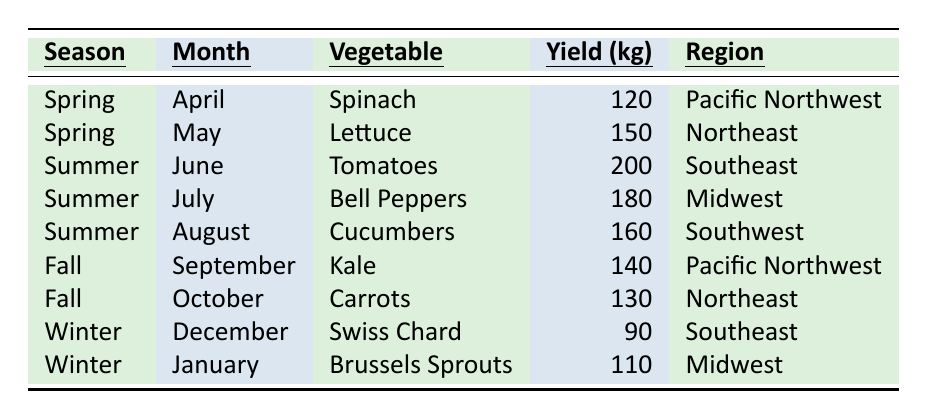What vegetables were harvested in the summer of 2023? In the table, under the summer season, the vegetables listed are Tomatoes in June, Bell Peppers in July, and Cucumbers in August.
Answer: Tomatoes, Bell Peppers, Cucumbers Which region yielded the highest amount of vegetables in 2023? The maximum yield in the table is 200 kg from the Southeast region for Tomatoes. Hence, the Southeast had the highest yield.
Answer: Southeast How many kg of Kale were harvested in the Fall? The yield of Kale mentioned in the table is 140 kg for Fall, specifically in September.
Answer: 140 kg What is the total yield of vegetables harvested in the winter? For winter, there are two vegetables: Swiss Chard in December with 90 kg and Brussels Sprouts in January with 110 kg. Adding these two yields gives 90 kg + 110 kg = 200 kg.
Answer: 200 kg Was the yield of Cucumbers higher than that of Lettuce? The yield for Cucumbers is 160 kg, while Lettuce's yield is 150 kg. Since 160 kg is greater than 150 kg, the statement is true.
Answer: Yes Calculate the average yield of vegetables across all seasons. The total yield from the table is 120 + 150 + 200 + 180 + 160 + 140 + 130 + 90 + 110 = 1,250 kg. There are 9 data points, thus the average yield is 1,250 kg / 9 ≈ 138.89 kg.
Answer: 138.89 kg How many vegetables were harvested in the Northeast region? There are two entries for the Northeast: Lettuce with 150 kg in May and Carrots with 130 kg in October. Therefore, two vegetables were harvested in this region.
Answer: 2 Which season had the least total yield of vegetables? The yields by season are: Spring (120 + 150 = 270), Summer (200 + 180 + 160 = 540), Fall (140 + 130 = 270), Winter (90 + 110 = 200). Winter has the least total yield; thus, it is the season with the least yield.
Answer: Winter List the regions with vegetable yields above 100 kg. From the table: Pacific Northwest (120 kg for Spinach, 140 kg for Kale), Northeast (150 kg for Lettuce, 130 kg for Carrots), Southeast (200 kg for Tomatoes, 90 kg for Swiss Chard), and Midwest (180 kg for Bell Peppers, 110 kg for Brussels Sprouts) have all yields above 100 kg. Regions are: Pacific Northwest, Northeast, Southeast, and Midwest.
Answer: Pacific Northwest, Northeast, Southeast, Midwest In which month was the highest yield of vegetables recorded, and what was the amount? The highest yield is 200 kg for Tomatoes harvested in June. Hence, June is the month with the highest yield.
Answer: June, 200 kg 